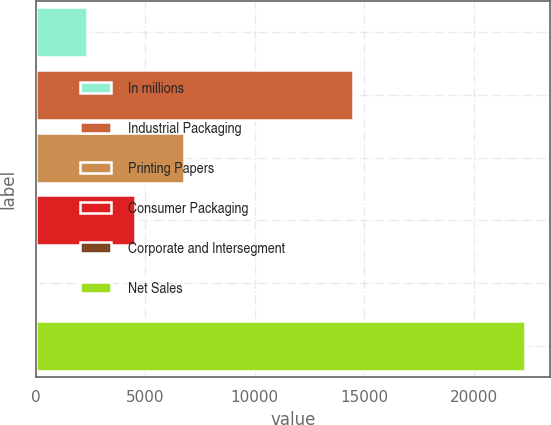<chart> <loc_0><loc_0><loc_500><loc_500><bar_chart><fcel>In millions<fcel>Industrial Packaging<fcel>Printing Papers<fcel>Consumer Packaging<fcel>Corporate and Intersegment<fcel>Net Sales<nl><fcel>2317.5<fcel>14484<fcel>6772.5<fcel>4545<fcel>90<fcel>22365<nl></chart> 